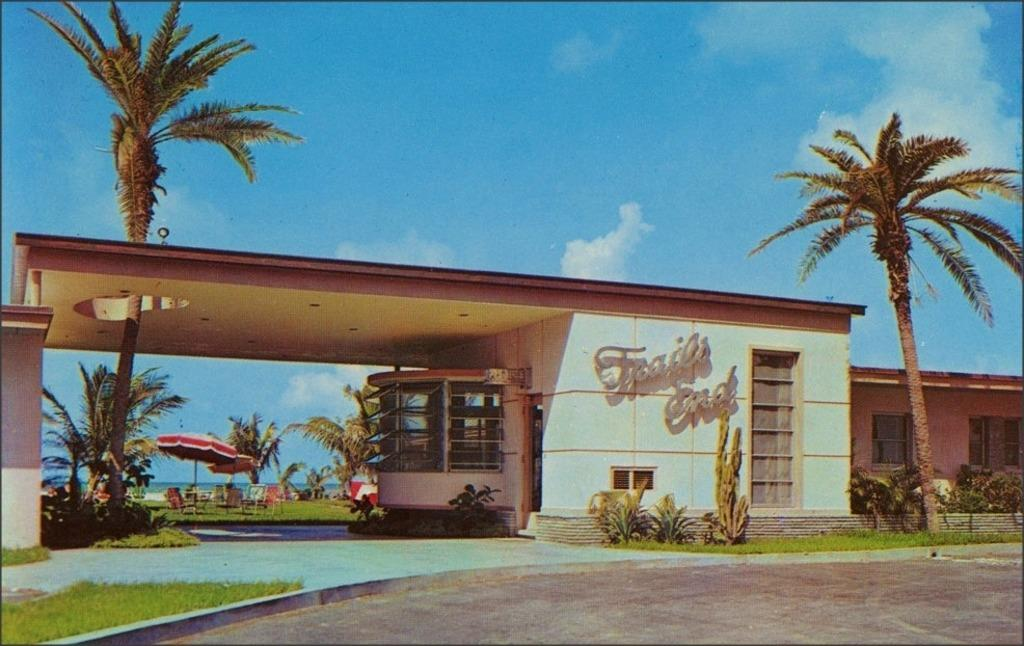What is the main structure visible in the image? There is a building in the image. Can you describe any text or writing on the building? Yes, there is something written on the building. What type of natural environment is visible in the background of the image? There are trees and greenery ground visible in the background of the image. What is the relation between the drop and the afterthought in the image? There is no drop or afterthought present in the image. 